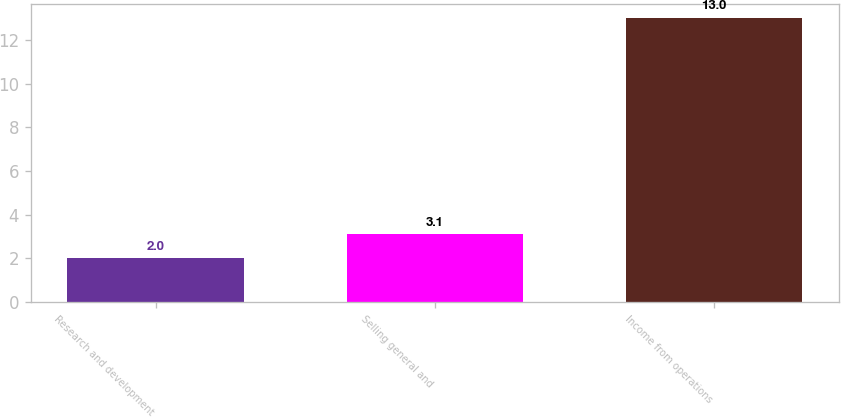<chart> <loc_0><loc_0><loc_500><loc_500><bar_chart><fcel>Research and development<fcel>Selling general and<fcel>Income from operations<nl><fcel>2<fcel>3.1<fcel>13<nl></chart> 